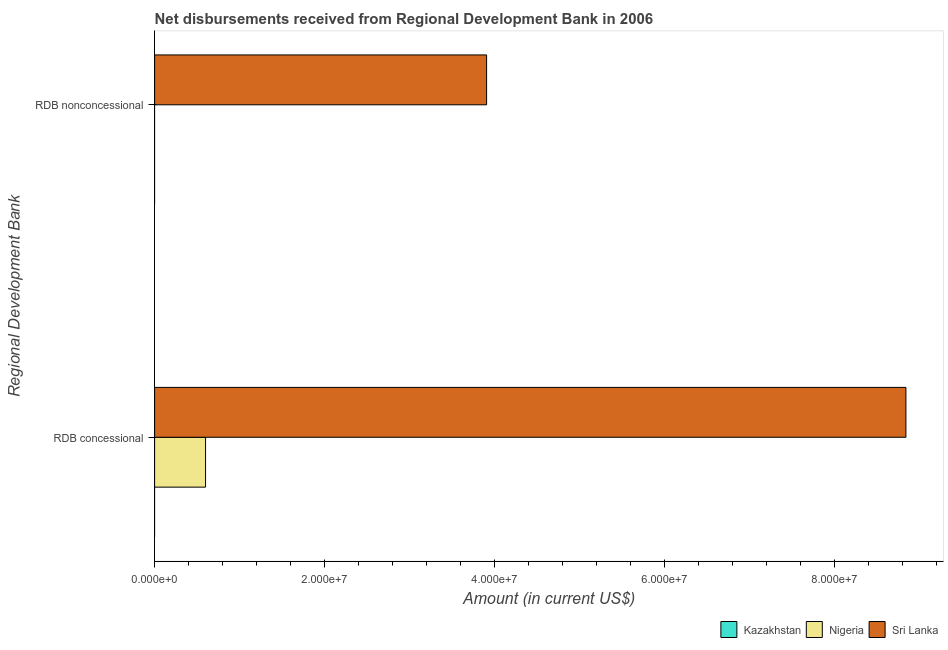How many different coloured bars are there?
Offer a very short reply. 2. Are the number of bars per tick equal to the number of legend labels?
Your answer should be compact. No. How many bars are there on the 1st tick from the bottom?
Keep it short and to the point. 2. What is the label of the 1st group of bars from the top?
Offer a terse response. RDB nonconcessional. What is the net non concessional disbursements from rdb in Kazakhstan?
Keep it short and to the point. 0. Across all countries, what is the maximum net concessional disbursements from rdb?
Your answer should be compact. 8.84e+07. Across all countries, what is the minimum net non concessional disbursements from rdb?
Your answer should be very brief. 0. In which country was the net non concessional disbursements from rdb maximum?
Provide a short and direct response. Sri Lanka. What is the total net concessional disbursements from rdb in the graph?
Ensure brevity in your answer.  9.44e+07. What is the difference between the net concessional disbursements from rdb in Sri Lanka and the net non concessional disbursements from rdb in Kazakhstan?
Ensure brevity in your answer.  8.84e+07. What is the average net concessional disbursements from rdb per country?
Give a very brief answer. 3.15e+07. What is the difference between the net non concessional disbursements from rdb and net concessional disbursements from rdb in Sri Lanka?
Ensure brevity in your answer.  -4.94e+07. In how many countries, is the net non concessional disbursements from rdb greater than the average net non concessional disbursements from rdb taken over all countries?
Offer a terse response. 1. How many bars are there?
Provide a short and direct response. 3. How many countries are there in the graph?
Offer a terse response. 3. What is the difference between two consecutive major ticks on the X-axis?
Your response must be concise. 2.00e+07. Does the graph contain grids?
Provide a short and direct response. No. How many legend labels are there?
Your answer should be very brief. 3. How are the legend labels stacked?
Offer a terse response. Horizontal. What is the title of the graph?
Ensure brevity in your answer.  Net disbursements received from Regional Development Bank in 2006. What is the label or title of the Y-axis?
Give a very brief answer. Regional Development Bank. What is the Amount (in current US$) of Kazakhstan in RDB concessional?
Provide a succinct answer. 0. What is the Amount (in current US$) of Nigeria in RDB concessional?
Keep it short and to the point. 6.00e+06. What is the Amount (in current US$) of Sri Lanka in RDB concessional?
Provide a short and direct response. 8.84e+07. What is the Amount (in current US$) in Kazakhstan in RDB nonconcessional?
Provide a succinct answer. 0. What is the Amount (in current US$) of Sri Lanka in RDB nonconcessional?
Your answer should be compact. 3.91e+07. Across all Regional Development Bank, what is the maximum Amount (in current US$) in Nigeria?
Provide a succinct answer. 6.00e+06. Across all Regional Development Bank, what is the maximum Amount (in current US$) of Sri Lanka?
Offer a terse response. 8.84e+07. Across all Regional Development Bank, what is the minimum Amount (in current US$) in Sri Lanka?
Offer a very short reply. 3.91e+07. What is the total Amount (in current US$) of Kazakhstan in the graph?
Your answer should be very brief. 0. What is the total Amount (in current US$) in Nigeria in the graph?
Offer a terse response. 6.00e+06. What is the total Amount (in current US$) of Sri Lanka in the graph?
Ensure brevity in your answer.  1.27e+08. What is the difference between the Amount (in current US$) of Sri Lanka in RDB concessional and that in RDB nonconcessional?
Keep it short and to the point. 4.94e+07. What is the difference between the Amount (in current US$) of Nigeria in RDB concessional and the Amount (in current US$) of Sri Lanka in RDB nonconcessional?
Your answer should be compact. -3.31e+07. What is the average Amount (in current US$) in Kazakhstan per Regional Development Bank?
Offer a terse response. 0. What is the average Amount (in current US$) of Nigeria per Regional Development Bank?
Provide a short and direct response. 3.00e+06. What is the average Amount (in current US$) of Sri Lanka per Regional Development Bank?
Your answer should be compact. 6.37e+07. What is the difference between the Amount (in current US$) in Nigeria and Amount (in current US$) in Sri Lanka in RDB concessional?
Provide a short and direct response. -8.24e+07. What is the ratio of the Amount (in current US$) of Sri Lanka in RDB concessional to that in RDB nonconcessional?
Your response must be concise. 2.26. What is the difference between the highest and the second highest Amount (in current US$) of Sri Lanka?
Offer a terse response. 4.94e+07. What is the difference between the highest and the lowest Amount (in current US$) in Nigeria?
Your response must be concise. 6.00e+06. What is the difference between the highest and the lowest Amount (in current US$) of Sri Lanka?
Give a very brief answer. 4.94e+07. 